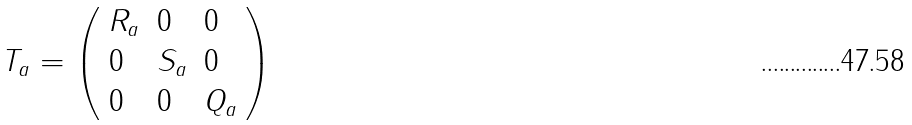Convert formula to latex. <formula><loc_0><loc_0><loc_500><loc_500>T _ { a } = \left ( \begin{array} { l l l } { { { R } _ { a } } } & { 0 } & { 0 } \\ { 0 } & { { { S } _ { a } } } & { 0 } \\ { 0 } & { 0 } & { { Q _ { a } } } \end{array} \right )</formula> 